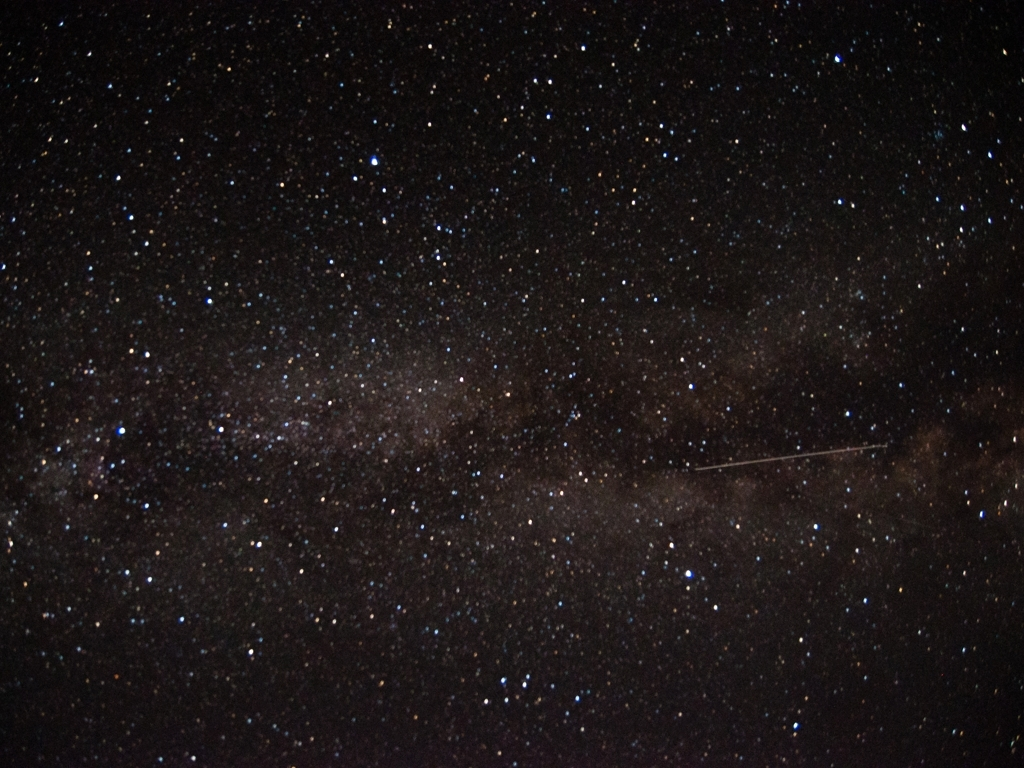Can you tell me more about what we're seeing in this night sky? Certainly! You're looking at a night sky filled with countless stars. The image captures a part of our galaxy, likely the Milky Way, as indicated by the dense band of stars and the darker regions caused by interstellar dust obscuring the starlight. There's also a faint streak on the right side, which could be a shooting star or satellite passing through the field of view, leaving a temporary trail in the exposure. 